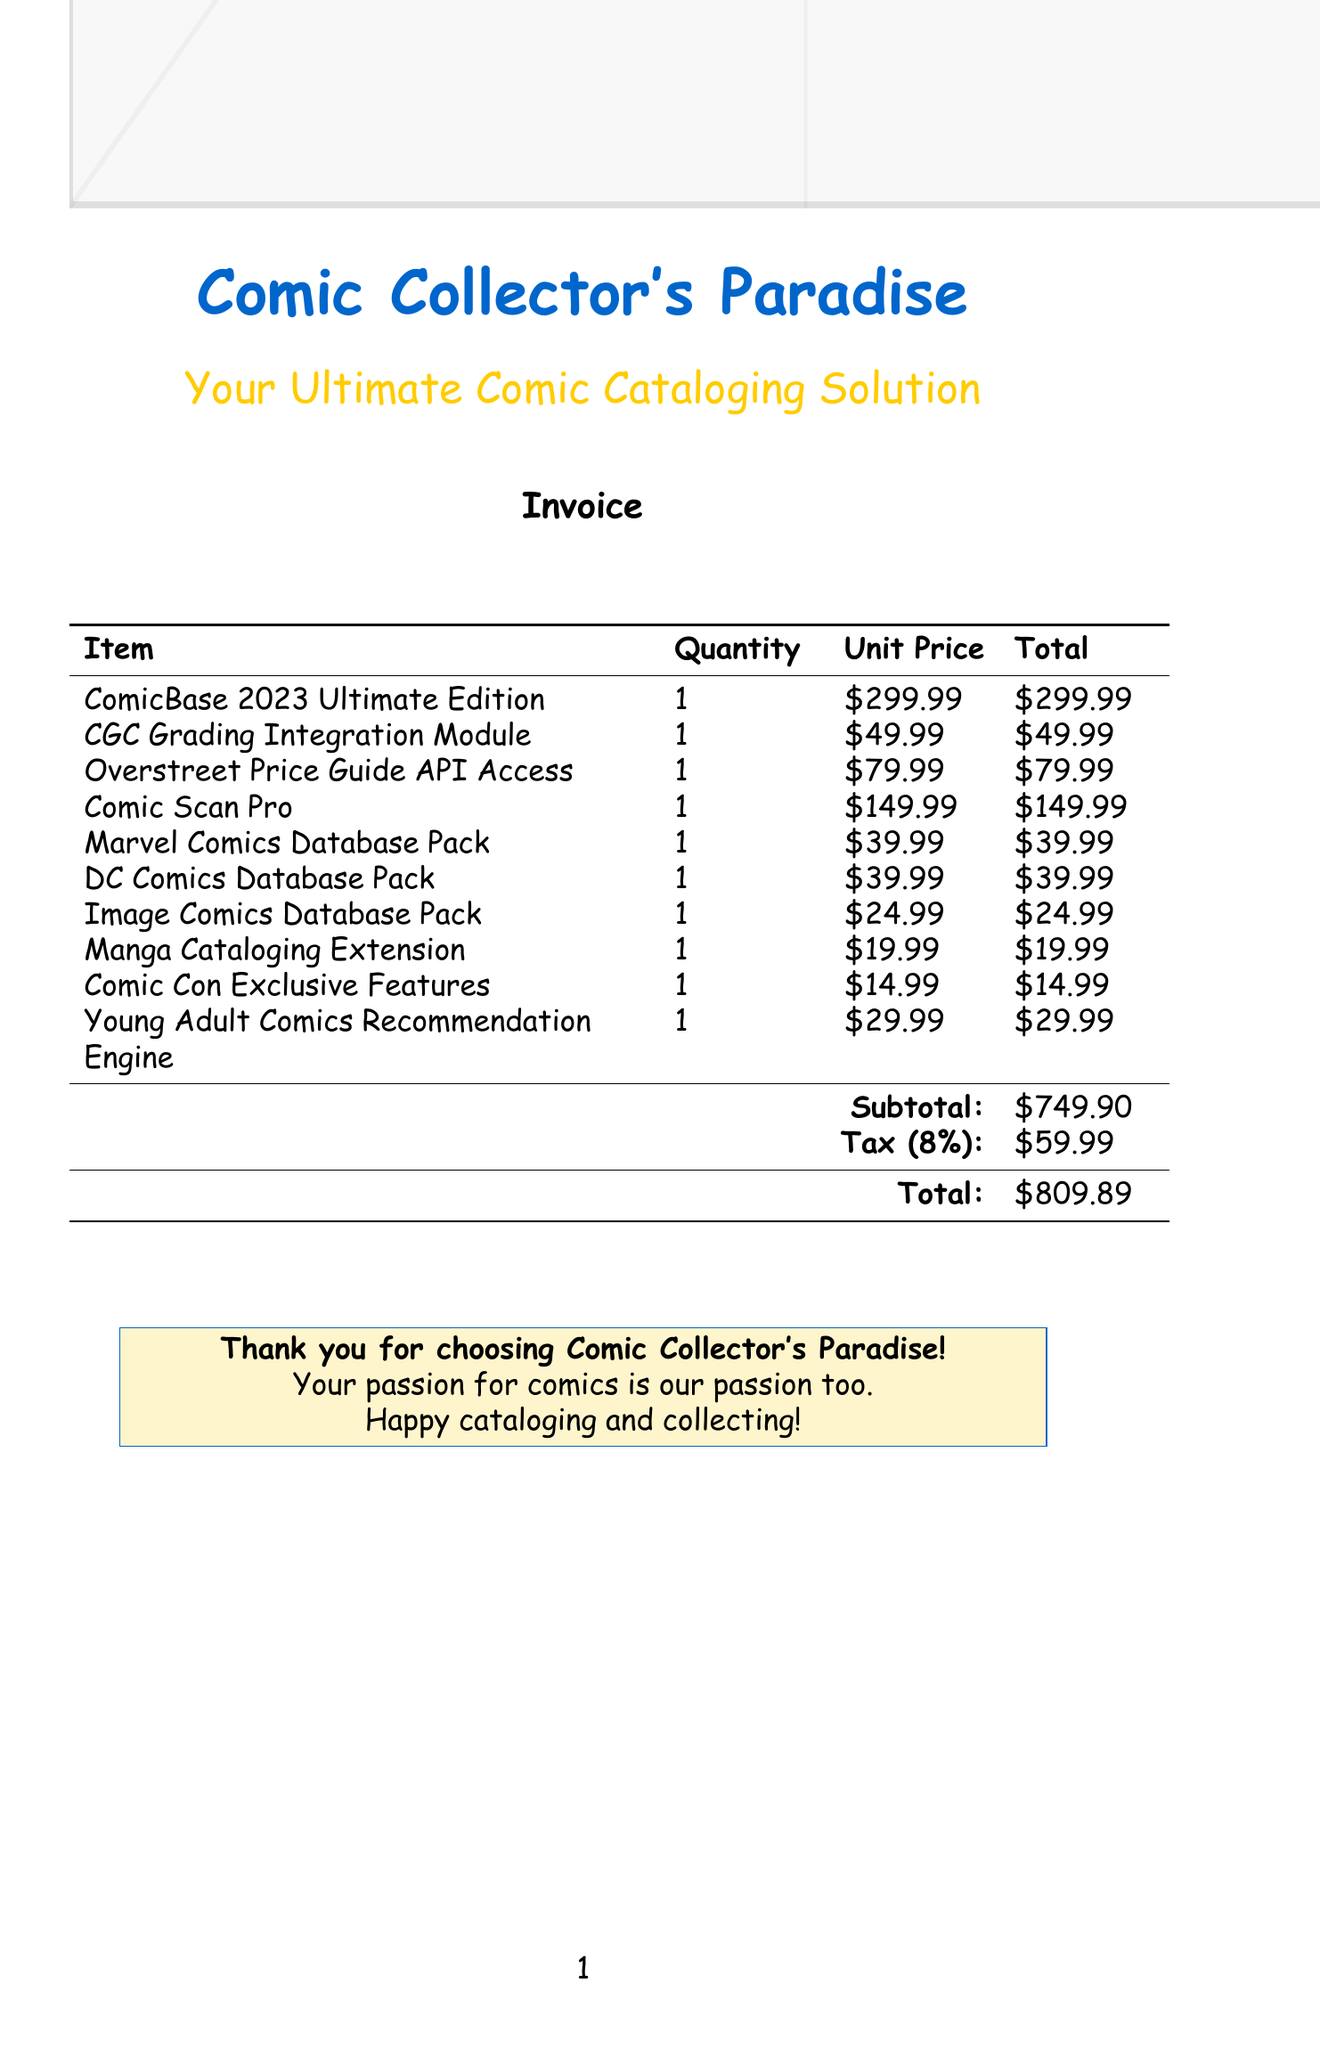What is the subtotal amount? The subtotal amount is explicitly listed in the document, showing a total before tax.
Answer: $749.90 What is the tax rate applied in this invoice? The document specifies an 8% tax rate applied to the subtotal.
Answer: 8% What add-on is for connecting to the CGC grading system? The invoice lists the CGC Grading Integration Module specifically for this purpose.
Answer: CGC Grading Integration Module What is included in the Young Adult Comics Recommendation Engine? The document describes it as an AI-powered tool for suggesting comics suitable for teenagers.
Answer: AI-powered tool for suggesting age-appropriate comics How many database packs are listed in the invoice? There are three different database packs mentioned for various comic publishers.
Answer: 3 What is the total amount due? The total amount due is clearly detailed at the end of the invoice, including the subtotal and tax.
Answer: $809.89 What is the purpose of the Comic Scan Pro item? The document describes it as an add-on for high-resolution scanning of comic book covers.
Answer: High-resolution scanner add-on Which database pack covers Marvel Comics? The document explicitly states the Marvel Comics Database Pack for this content.
Answer: Marvel Comics Database Pack 